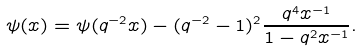<formula> <loc_0><loc_0><loc_500><loc_500>\psi ( x ) = \psi ( q ^ { - 2 } x ) - ( q ^ { - 2 } - 1 ) ^ { 2 } \frac { q ^ { 4 } x ^ { - 1 } } { 1 - q ^ { 2 } x ^ { - 1 } } .</formula> 